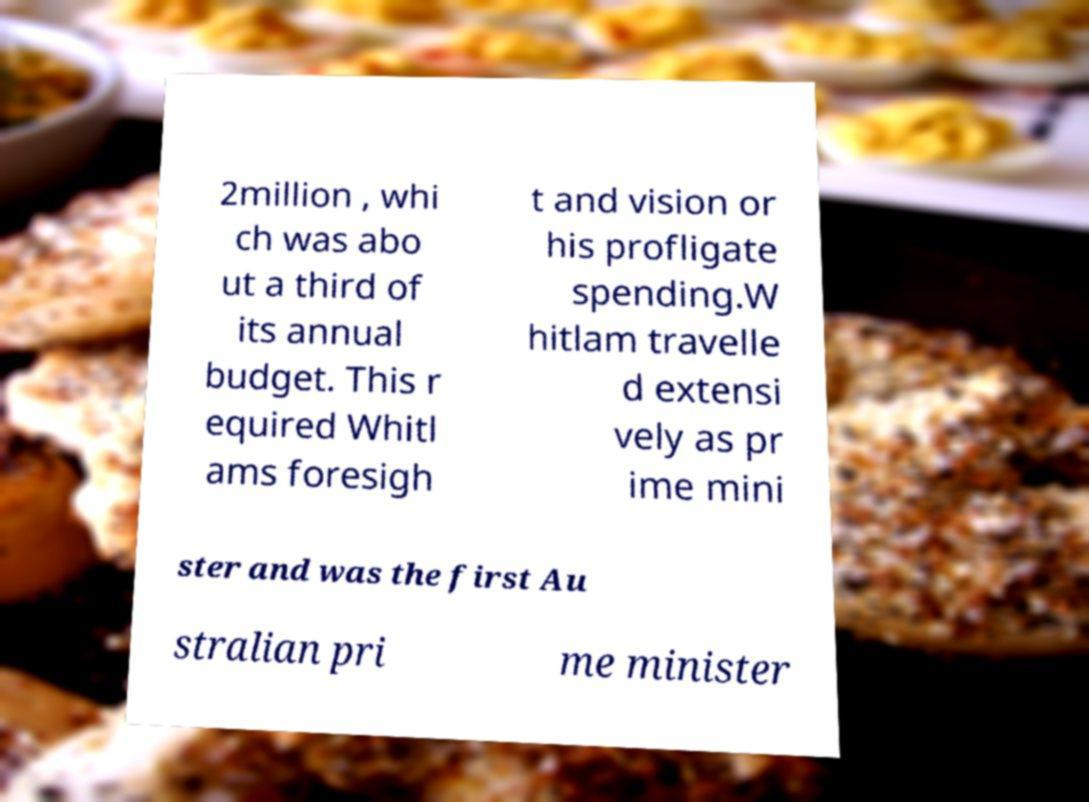Could you assist in decoding the text presented in this image and type it out clearly? 2million , whi ch was abo ut a third of its annual budget. This r equired Whitl ams foresigh t and vision or his profligate spending.W hitlam travelle d extensi vely as pr ime mini ster and was the first Au stralian pri me minister 